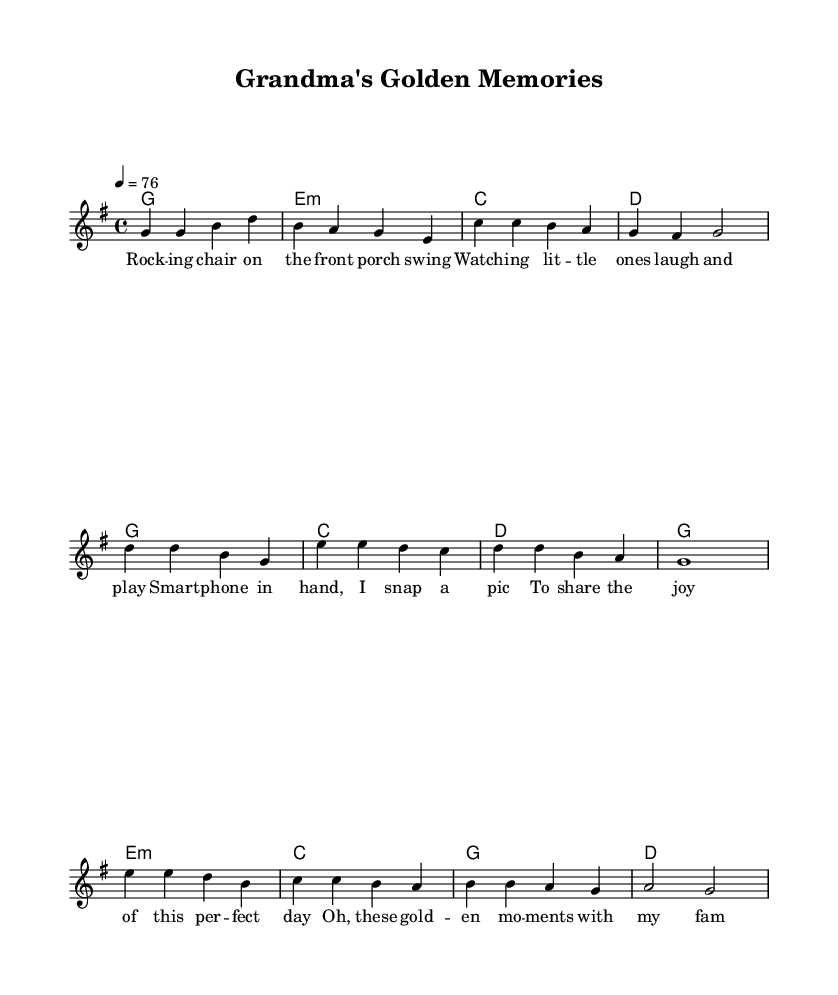What is the key signature of this music? The key signature is G major, which contains one sharp (F#). This can be identified at the beginning of the music sheet, where the key signature is indicated.
Answer: G major What is the time signature of this piece? The time signature is 4/4, which is also shown at the beginning of the music sheet. This means there are four beats in a measure, and the quarter note gets one beat.
Answer: 4/4 What is the tempo marking for this song? The tempo is marked as quarter note equals 76 beats per minute. This indicates how fast the music should be played, and it is specified in the tempo instruction.
Answer: 76 How many measures are in the verse section? The verse section consists of 4 measures, as counts can be conducted for each line of melody in the verse lyrics, grouping them accordingly.
Answer: 4 Which chord is used in the chorus? The chorus includes the chords G, C, and D. These chords are listed in the harmonies section that align with the chorus lyrics, which depict the song's structure.
Answer: G, C, D What is the lyrical theme of the song? The lyrical theme revolves around family memories and cherishing moments spent with grandchildren, as highlighted explicitly in the lyrics provided in the music sheet.
Answer: Family memories What is the bridge's contribution to the song's emotional tone? The bridge reflects on the passage of time and the lasting nature of memories, which adds depth and emotional resonance to the overall song when examined alongside the lyrics and structure.
Answer: Emotional depth 